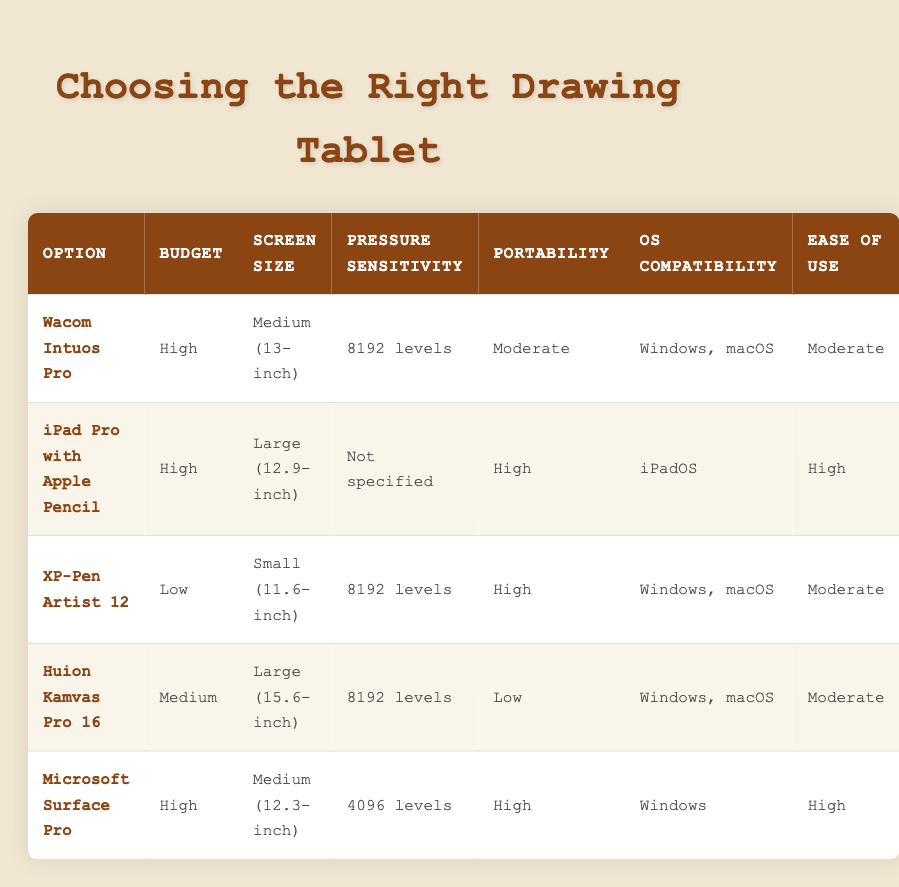What is the budget range for the XP-Pen Artist 12? The table lists the budget for the XP-Pen Artist 12 as "Low."
Answer: Low Which option has the largest screen size? The iPad Pro with Apple Pencil has a screen size of "Large (12.9-inch)," making it the largest in the table.
Answer: iPad Pro with Apple Pencil Is the Wacom Intuos Pro portable? The table shows that the portability of the Wacom Intuos Pro is categorized as "Moderate," indicating it is somewhat portable but not the best option in that category.
Answer: No What is the average pressure sensitivity across all options? The pressure sensitivity values are 8192, 8192, 8192, and 4096 levels for Wacom Intuos Pro, XP-Pen Artist 12, Huion Kamvas Pro 16, and Microsoft Surface Pro respectively. The average is calculated as (8192 + 8192 + 8192 + 4096) / 4 = 7668 levels.
Answer: 7668 levels Which option is compatible with iPadOS? The table indicates that the iPad Pro with Apple Pencil is the only option that lists "iPadOS" under operating system compatibility.
Answer: iPad Pro with Apple Pencil Is there any drawing tablet with high portability and low budget? The table shows that the XP-Pen Artist 12 is high in portability and classified as a low budget option, thus it meets the criteria.
Answer: Yes What option has the highest ease of use? The iPad Pro with Apple Pencil and the Microsoft Surface Pro both have "High" listed for ease of use, making them the top performers in this category.
Answer: iPad Pro with Apple Pencil and Microsoft Surface Pro How does the pressure sensitivity of the Microsoft Surface Pro compare to the Wacom Intuos Pro? The Microsoft Surface Pro has a pressure sensitivity of 4096 levels, while the Wacom Intuos Pro has 8192 levels, indicating that the Wacom Intuos Pro has double the sensitivity.
Answer: Wacom Intuos Pro is higher Which two options are compatible with both Windows and macOS? The Wacom Intuos Pro, XP-Pen Artist 12, and Huion Kamvas Pro 16 are compatible with both Windows and macOS; thus, the answer indicates that there are three options, not just two.
Answer: Wacom Intuos Pro, XP-Pen Artist 12, Huion Kamvas Pro 16 